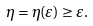Convert formula to latex. <formula><loc_0><loc_0><loc_500><loc_500>\eta = \eta ( \varepsilon ) \geq \varepsilon .</formula> 